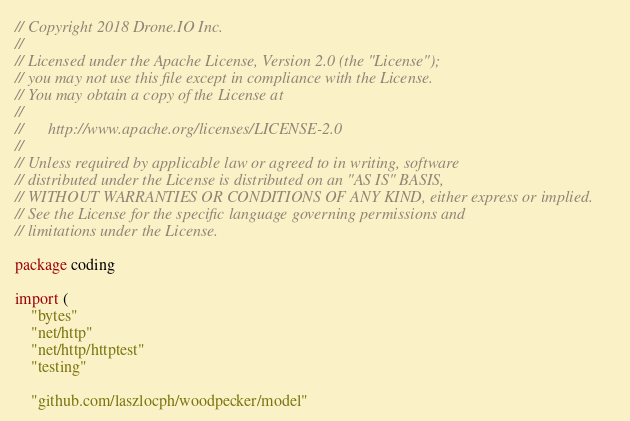<code> <loc_0><loc_0><loc_500><loc_500><_Go_>// Copyright 2018 Drone.IO Inc.
//
// Licensed under the Apache License, Version 2.0 (the "License");
// you may not use this file except in compliance with the License.
// You may obtain a copy of the License at
//
//      http://www.apache.org/licenses/LICENSE-2.0
//
// Unless required by applicable law or agreed to in writing, software
// distributed under the License is distributed on an "AS IS" BASIS,
// WITHOUT WARRANTIES OR CONDITIONS OF ANY KIND, either express or implied.
// See the License for the specific language governing permissions and
// limitations under the License.

package coding

import (
	"bytes"
	"net/http"
	"net/http/httptest"
	"testing"

	"github.com/laszlocph/woodpecker/model"</code> 